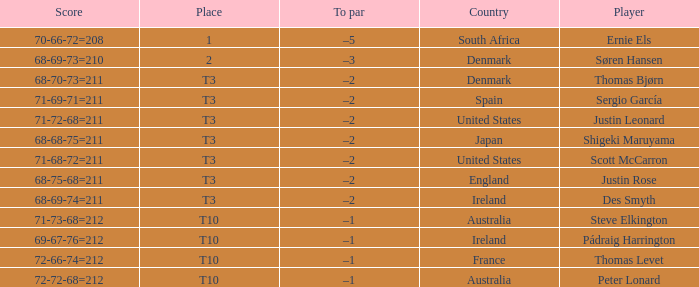What was the place when the score was 71-69-71=211? T3. 